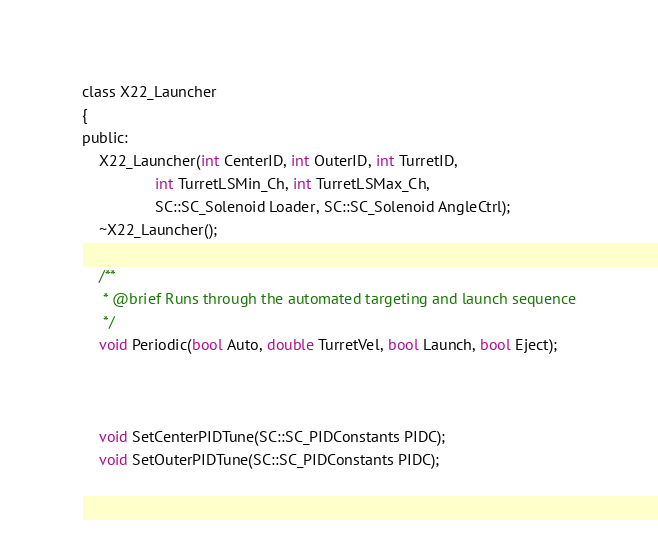Convert code to text. <code><loc_0><loc_0><loc_500><loc_500><_C_>
class X22_Launcher
{
public:
	X22_Launcher(int CenterID, int OuterID, int TurretID,
	 			 int TurretLSMin_Ch, int TurretLSMax_Ch, 
				 SC::SC_Solenoid Loader, SC::SC_Solenoid AngleCtrl);
	~X22_Launcher();

	/**
	 * @brief Runs through the automated targeting and launch sequence
	 */
	void Periodic(bool Auto, double TurretVel, bool Launch, bool Eject);



	void SetCenterPIDTune(SC::SC_PIDConstants PIDC);
	void SetOuterPIDTune(SC::SC_PIDConstants PIDC);
</code> 